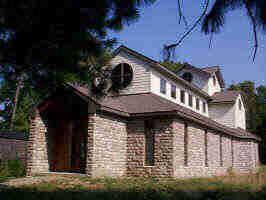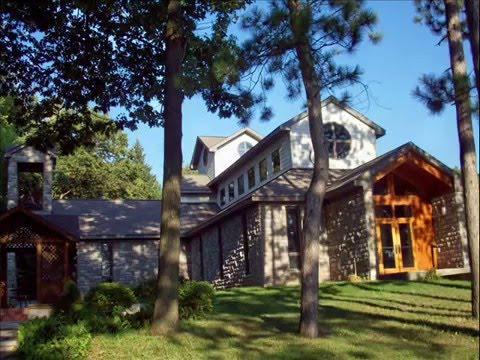The first image is the image on the left, the second image is the image on the right. Evaluate the accuracy of this statement regarding the images: "A bell tower is visible in at least one image.". Is it true? Answer yes or no. No. 